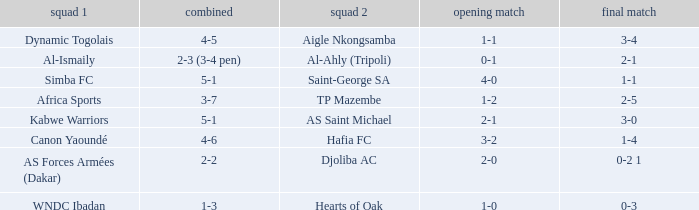What was the 2nd leg result in the match that scored a 2-0 in the 1st leg? 0-2 1. 